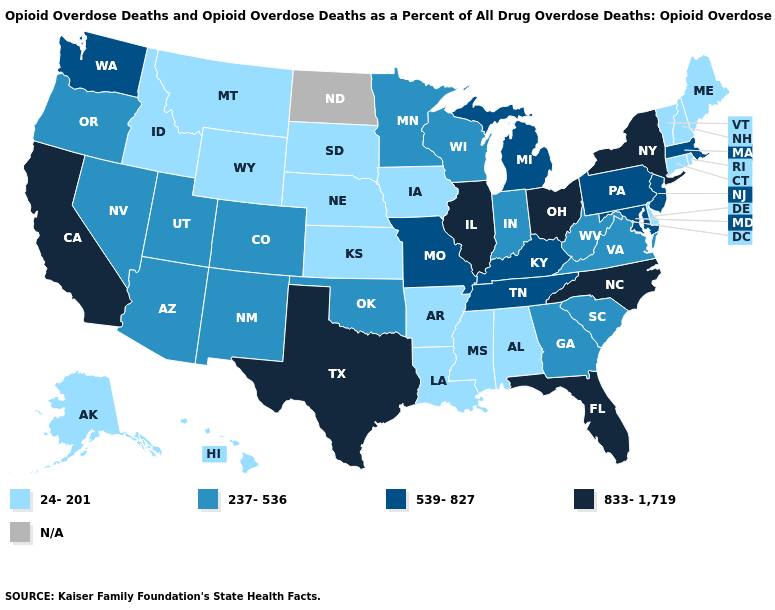Among the states that border Maine , which have the lowest value?
Be succinct. New Hampshire. How many symbols are there in the legend?
Be succinct. 5. What is the highest value in the USA?
Answer briefly. 833-1,719. What is the value of Washington?
Keep it brief. 539-827. Name the states that have a value in the range N/A?
Give a very brief answer. North Dakota. Name the states that have a value in the range N/A?
Write a very short answer. North Dakota. What is the value of Alaska?
Short answer required. 24-201. Which states hav the highest value in the South?
Answer briefly. Florida, North Carolina, Texas. What is the lowest value in the South?
Be succinct. 24-201. What is the value of Louisiana?
Concise answer only. 24-201. What is the value of Alaska?
Write a very short answer. 24-201. Does the first symbol in the legend represent the smallest category?
Short answer required. Yes. Among the states that border Virginia , does North Carolina have the highest value?
Concise answer only. Yes. Which states hav the highest value in the Northeast?
Answer briefly. New York. 